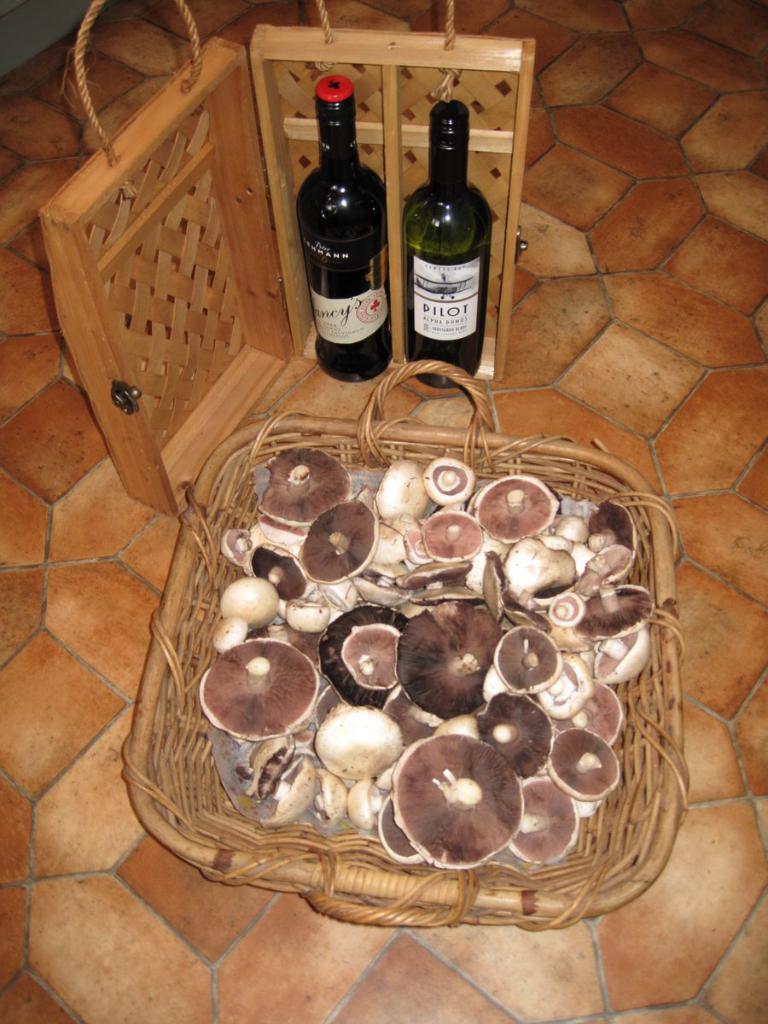What is the bottle on the right?
Ensure brevity in your answer.  Pilot. 